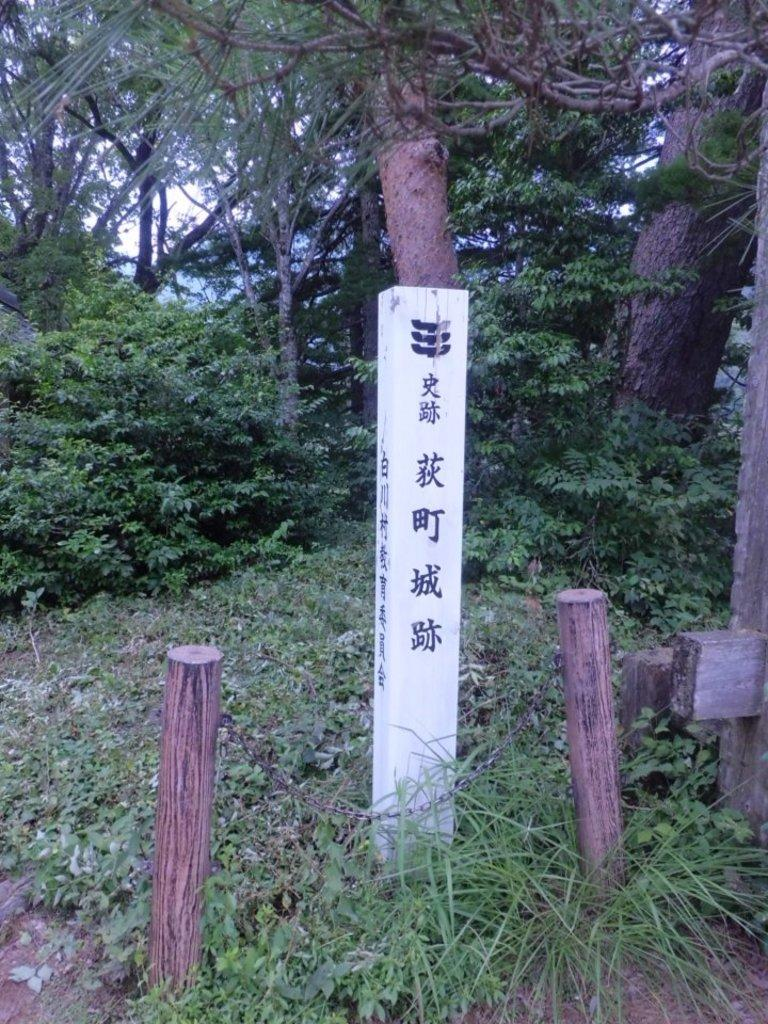What is the main object in the center of the image? There is a wooden log with signs in the center of the image. What can be seen in the background of the image? There are trees in the background of the image. What other wooden logs are visible in the image? There are wooden logs in the front of the image. What type of ground is visible in the image? There is grass on the ground. What type of sound can be heard coming from the wooden log in the image? There is no sound coming from the wooden log in the image. What type of flesh can be seen on the wooden log in the image? There is no flesh present on the wooden log in the image. 